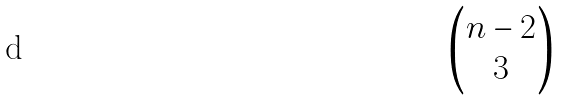<formula> <loc_0><loc_0><loc_500><loc_500>\begin{pmatrix} n - 2 \\ 3 \\ \end{pmatrix}</formula> 